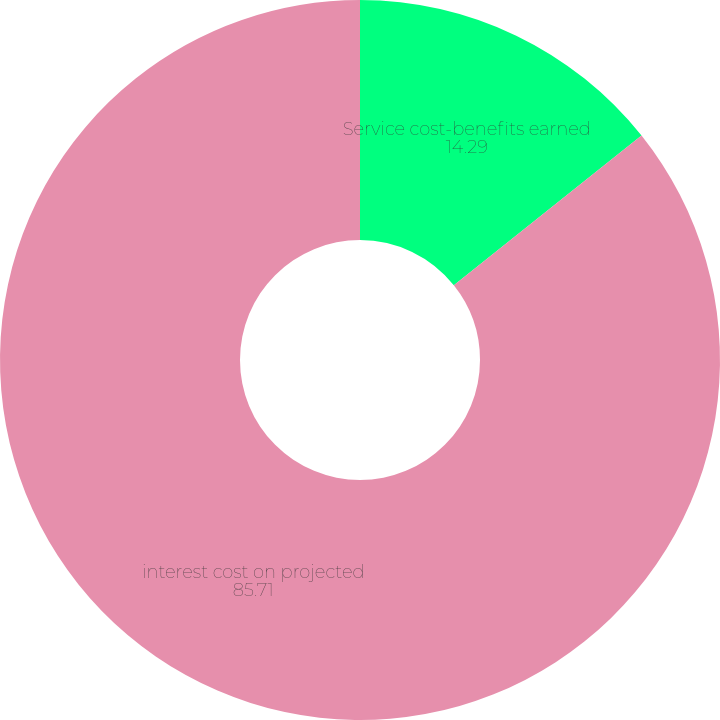Convert chart. <chart><loc_0><loc_0><loc_500><loc_500><pie_chart><fcel>Service cost-benefits earned<fcel>interest cost on projected<nl><fcel>14.29%<fcel>85.71%<nl></chart> 